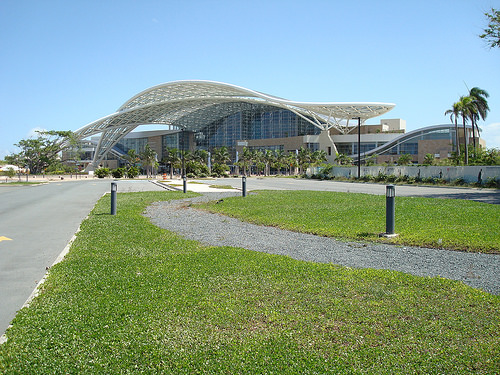<image>
Is there a road next to the grass? Yes. The road is positioned adjacent to the grass, located nearby in the same general area. 